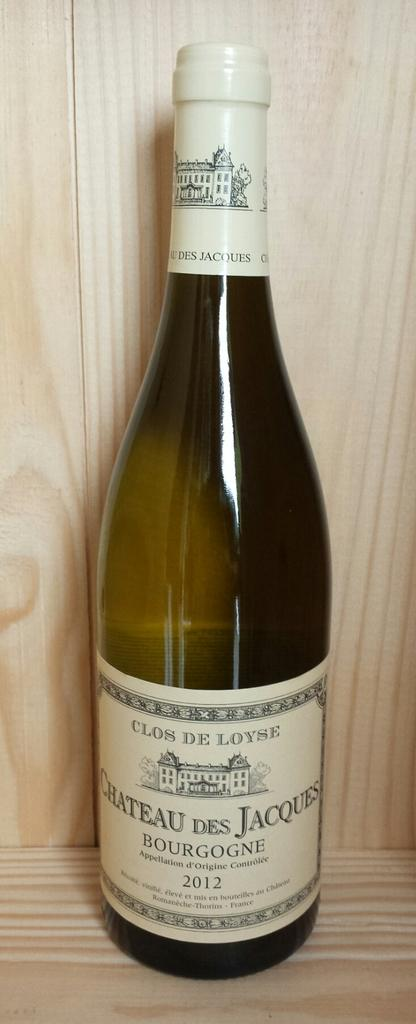Provide a one-sentence caption for the provided image. a new unopened bottle of chateau des jaques in a cupboard. 